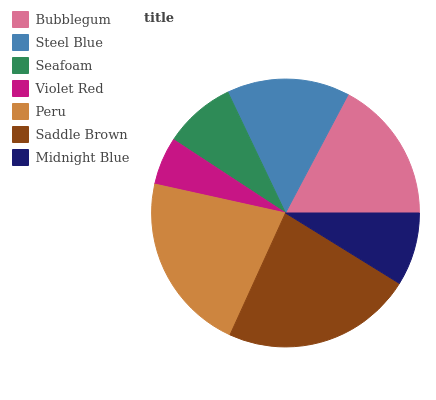Is Violet Red the minimum?
Answer yes or no. Yes. Is Saddle Brown the maximum?
Answer yes or no. Yes. Is Steel Blue the minimum?
Answer yes or no. No. Is Steel Blue the maximum?
Answer yes or no. No. Is Bubblegum greater than Steel Blue?
Answer yes or no. Yes. Is Steel Blue less than Bubblegum?
Answer yes or no. Yes. Is Steel Blue greater than Bubblegum?
Answer yes or no. No. Is Bubblegum less than Steel Blue?
Answer yes or no. No. Is Steel Blue the high median?
Answer yes or no. Yes. Is Steel Blue the low median?
Answer yes or no. Yes. Is Midnight Blue the high median?
Answer yes or no. No. Is Midnight Blue the low median?
Answer yes or no. No. 